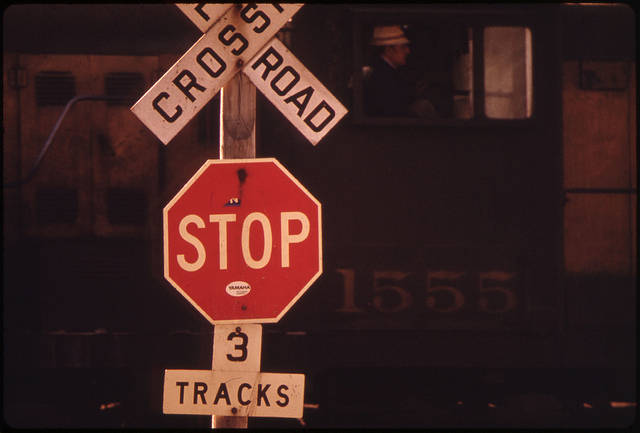Please extract the text content from this image. 1555 STOP TRACKS 3 CROSS ROAD 